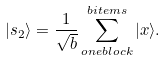<formula> <loc_0><loc_0><loc_500><loc_500>| s _ { 2 } \rangle = \frac { 1 } { \sqrt { b } } \sum _ { o n e b l o c k } ^ { b i t e m s } | x \rangle .</formula> 